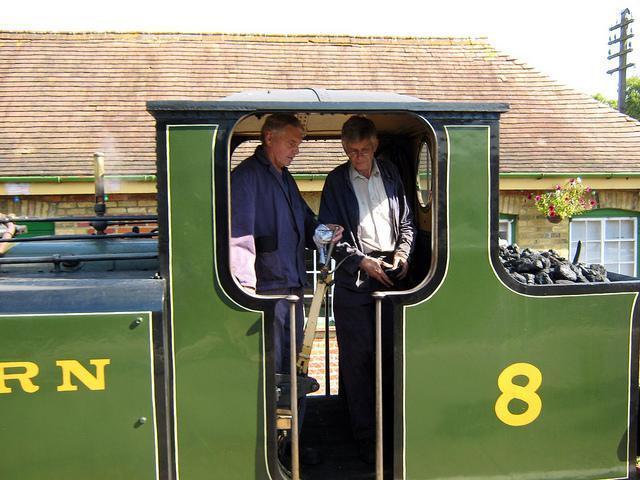How many people are in the photo?
Give a very brief answer. 2. 